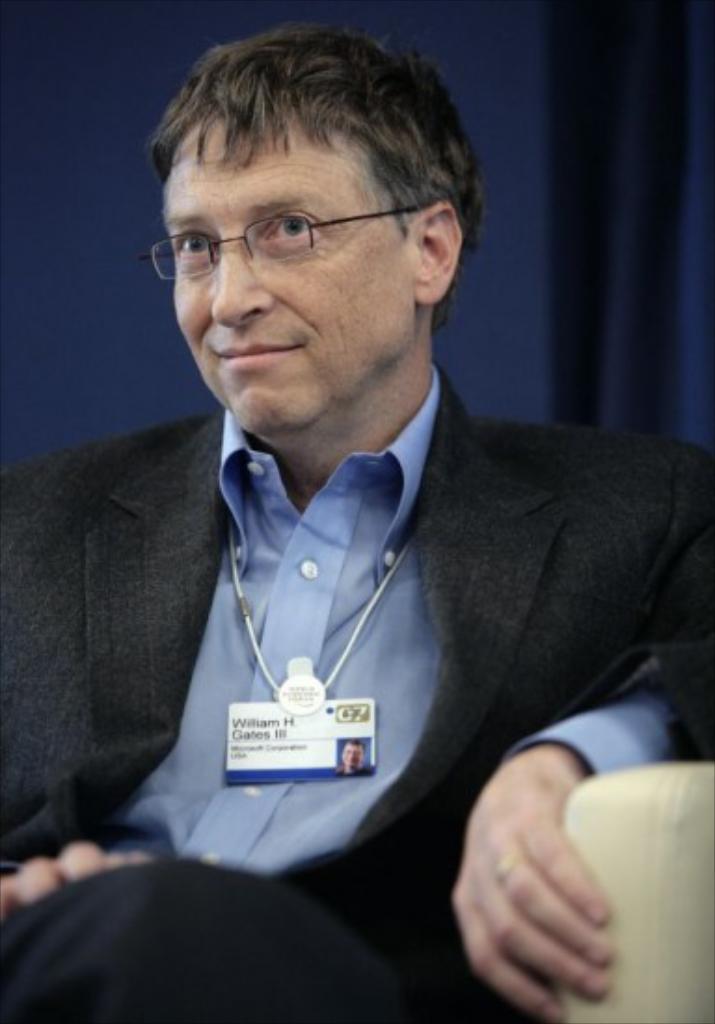Can you describe this image briefly? In this image we can see a person sitting on a chair. In the background, we can see the curtains. 